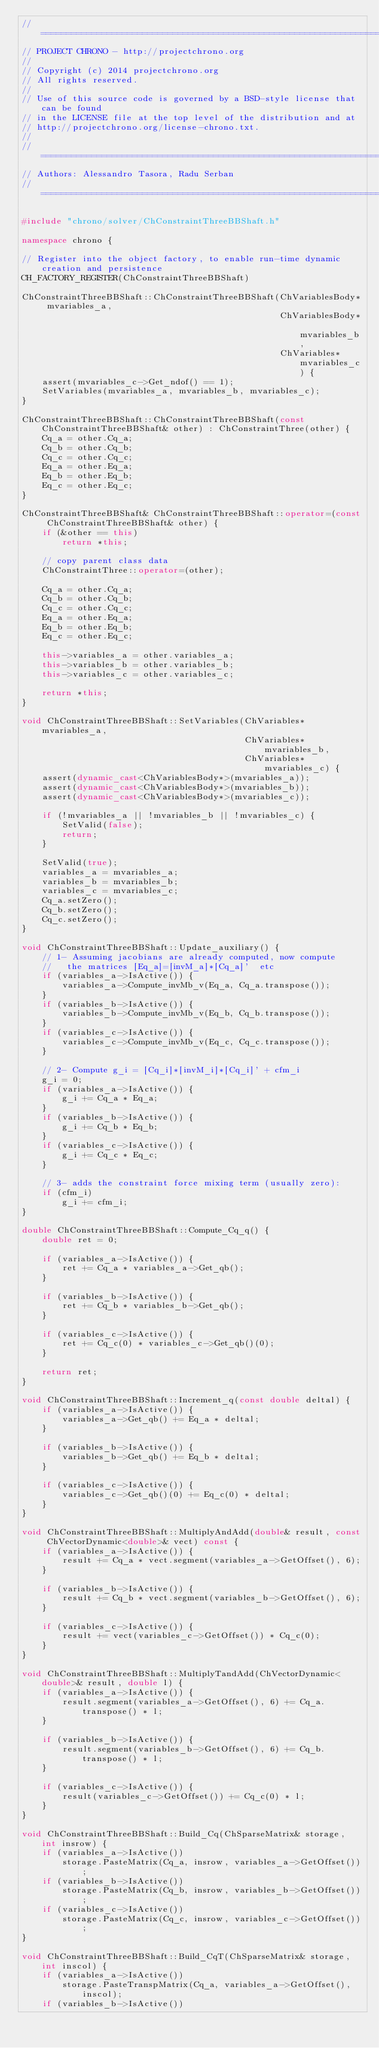Convert code to text. <code><loc_0><loc_0><loc_500><loc_500><_C++_>// =============================================================================
// PROJECT CHRONO - http://projectchrono.org
//
// Copyright (c) 2014 projectchrono.org
// All rights reserved.
//
// Use of this source code is governed by a BSD-style license that can be found
// in the LICENSE file at the top level of the distribution and at
// http://projectchrono.org/license-chrono.txt.
//
// =============================================================================
// Authors: Alessandro Tasora, Radu Serban
// =============================================================================

#include "chrono/solver/ChConstraintThreeBBShaft.h"

namespace chrono {

// Register into the object factory, to enable run-time dynamic creation and persistence
CH_FACTORY_REGISTER(ChConstraintThreeBBShaft)

ChConstraintThreeBBShaft::ChConstraintThreeBBShaft(ChVariablesBody* mvariables_a,
                                                   ChVariablesBody* mvariables_b,
                                                   ChVariables* mvariables_c) {
    assert(mvariables_c->Get_ndof() == 1);
    SetVariables(mvariables_a, mvariables_b, mvariables_c);
}

ChConstraintThreeBBShaft::ChConstraintThreeBBShaft(const ChConstraintThreeBBShaft& other) : ChConstraintThree(other) {
    Cq_a = other.Cq_a;
    Cq_b = other.Cq_b;
    Cq_c = other.Cq_c;
    Eq_a = other.Eq_a;
    Eq_b = other.Eq_b;
    Eq_c = other.Eq_c;
}

ChConstraintThreeBBShaft& ChConstraintThreeBBShaft::operator=(const ChConstraintThreeBBShaft& other) {
    if (&other == this)
        return *this;

    // copy parent class data
    ChConstraintThree::operator=(other);

    Cq_a = other.Cq_a;
    Cq_b = other.Cq_b;
    Cq_c = other.Cq_c;
    Eq_a = other.Eq_a;
    Eq_b = other.Eq_b;
    Eq_c = other.Eq_c;

    this->variables_a = other.variables_a;
    this->variables_b = other.variables_b;
    this->variables_c = other.variables_c;

    return *this;
}

void ChConstraintThreeBBShaft::SetVariables(ChVariables* mvariables_a,
                                            ChVariables* mvariables_b,
                                            ChVariables* mvariables_c) {
    assert(dynamic_cast<ChVariablesBody*>(mvariables_a));
    assert(dynamic_cast<ChVariablesBody*>(mvariables_b));
    assert(dynamic_cast<ChVariablesBody*>(mvariables_c));

    if (!mvariables_a || !mvariables_b || !mvariables_c) {
        SetValid(false);
        return;
    }

    SetValid(true);
    variables_a = mvariables_a;
    variables_b = mvariables_b;
    variables_c = mvariables_c;
    Cq_a.setZero();
    Cq_b.setZero();
    Cq_c.setZero();
}

void ChConstraintThreeBBShaft::Update_auxiliary() {
    // 1- Assuming jacobians are already computed, now compute
    //   the matrices [Eq_a]=[invM_a]*[Cq_a]'  etc
    if (variables_a->IsActive()) {
        variables_a->Compute_invMb_v(Eq_a, Cq_a.transpose());
    }
    if (variables_b->IsActive()) {
        variables_b->Compute_invMb_v(Eq_b, Cq_b.transpose());
    }
    if (variables_c->IsActive()) {
        variables_c->Compute_invMb_v(Eq_c, Cq_c.transpose());
    }

    // 2- Compute g_i = [Cq_i]*[invM_i]*[Cq_i]' + cfm_i
    g_i = 0;
    if (variables_a->IsActive()) {
        g_i += Cq_a * Eq_a;
    }
    if (variables_b->IsActive()) {
        g_i += Cq_b * Eq_b;
    }
    if (variables_c->IsActive()) {
        g_i += Cq_c * Eq_c;
    }

    // 3- adds the constraint force mixing term (usually zero):
    if (cfm_i)
        g_i += cfm_i;
}

double ChConstraintThreeBBShaft::Compute_Cq_q() {
    double ret = 0;

    if (variables_a->IsActive()) {
        ret += Cq_a * variables_a->Get_qb();
    }

    if (variables_b->IsActive()) {
        ret += Cq_b * variables_b->Get_qb();
    }

    if (variables_c->IsActive()) {
        ret += Cq_c(0) * variables_c->Get_qb()(0);
    }

    return ret;
}

void ChConstraintThreeBBShaft::Increment_q(const double deltal) {
    if (variables_a->IsActive()) {
        variables_a->Get_qb() += Eq_a * deltal;
    }

    if (variables_b->IsActive()) {
        variables_b->Get_qb() += Eq_b * deltal;
    }

    if (variables_c->IsActive()) {
        variables_c->Get_qb()(0) += Eq_c(0) * deltal;
    }
}

void ChConstraintThreeBBShaft::MultiplyAndAdd(double& result, const ChVectorDynamic<double>& vect) const {
    if (variables_a->IsActive()) {
        result += Cq_a * vect.segment(variables_a->GetOffset(), 6);
    }

    if (variables_b->IsActive()) {
        result += Cq_b * vect.segment(variables_b->GetOffset(), 6);
    }

    if (variables_c->IsActive()) {
        result += vect(variables_c->GetOffset()) * Cq_c(0);
    }
}

void ChConstraintThreeBBShaft::MultiplyTandAdd(ChVectorDynamic<double>& result, double l) {
    if (variables_a->IsActive()) {
        result.segment(variables_a->GetOffset(), 6) += Cq_a.transpose() * l;
    }

    if (variables_b->IsActive()) {
        result.segment(variables_b->GetOffset(), 6) += Cq_b.transpose() * l;
    }

    if (variables_c->IsActive()) {
        result(variables_c->GetOffset()) += Cq_c(0) * l;
    }
}

void ChConstraintThreeBBShaft::Build_Cq(ChSparseMatrix& storage, int insrow) {
    if (variables_a->IsActive())
        storage.PasteMatrix(Cq_a, insrow, variables_a->GetOffset());
    if (variables_b->IsActive())
        storage.PasteMatrix(Cq_b, insrow, variables_b->GetOffset());
    if (variables_c->IsActive())
        storage.PasteMatrix(Cq_c, insrow, variables_c->GetOffset());
}

void ChConstraintThreeBBShaft::Build_CqT(ChSparseMatrix& storage, int inscol) {
    if (variables_a->IsActive())
        storage.PasteTranspMatrix(Cq_a, variables_a->GetOffset(), inscol);
    if (variables_b->IsActive())</code> 